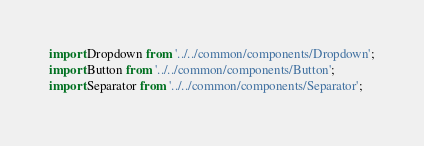<code> <loc_0><loc_0><loc_500><loc_500><_JavaScript_>import Dropdown from '../../common/components/Dropdown';
import Button from '../../common/components/Button';
import Separator from '../../common/components/Separator';</code> 